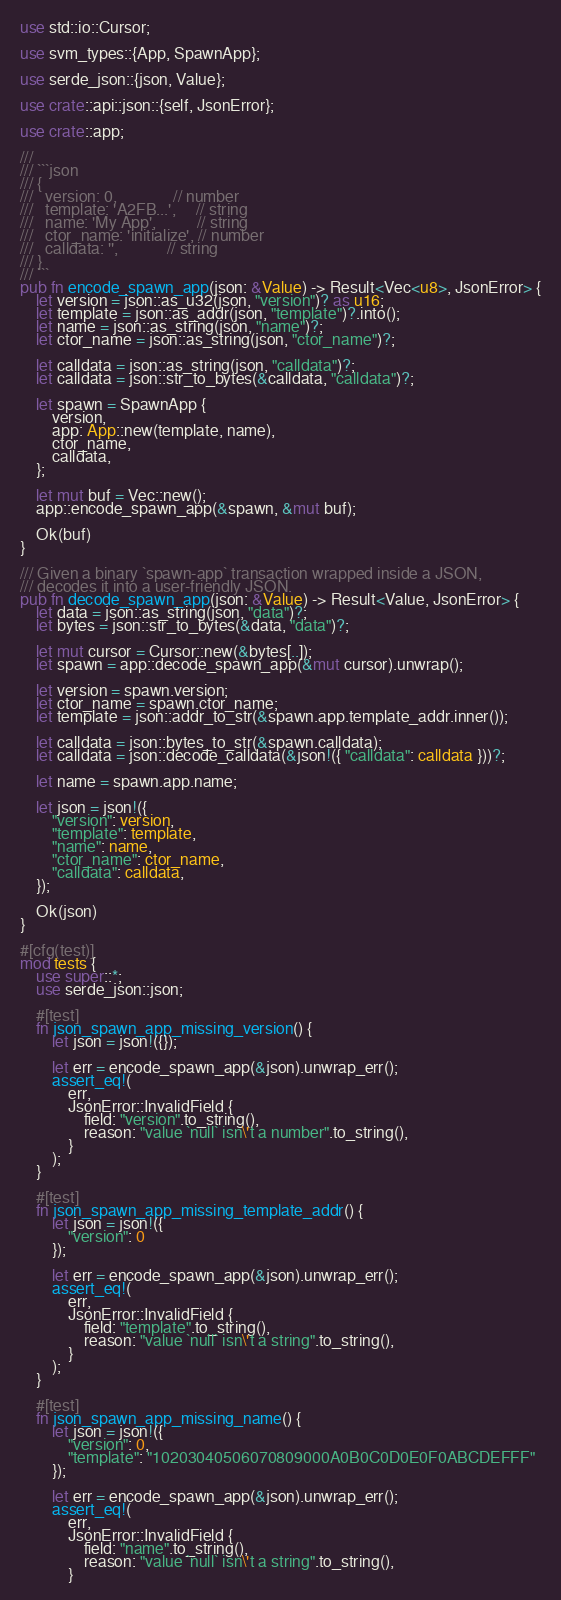<code> <loc_0><loc_0><loc_500><loc_500><_Rust_>use std::io::Cursor;

use svm_types::{App, SpawnApp};

use serde_json::{json, Value};

use crate::api::json::{self, JsonError};

use crate::app;

///
/// ```json
/// {
///   version: 0,              // number
///   template: 'A2FB...',     // string
///   name: 'My App',          // string
///   ctor_name: 'initialize', // number
///   calldata: '',            // string
/// }
/// ```
pub fn encode_spawn_app(json: &Value) -> Result<Vec<u8>, JsonError> {
    let version = json::as_u32(json, "version")? as u16;
    let template = json::as_addr(json, "template")?.into();
    let name = json::as_string(json, "name")?;
    let ctor_name = json::as_string(json, "ctor_name")?;

    let calldata = json::as_string(json, "calldata")?;
    let calldata = json::str_to_bytes(&calldata, "calldata")?;

    let spawn = SpawnApp {
        version,
        app: App::new(template, name),
        ctor_name,
        calldata,
    };

    let mut buf = Vec::new();
    app::encode_spawn_app(&spawn, &mut buf);

    Ok(buf)
}

/// Given a binary `spawn-app` transaction wrapped inside a JSON,
/// decodes it into a user-friendly JSON.
pub fn decode_spawn_app(json: &Value) -> Result<Value, JsonError> {
    let data = json::as_string(json, "data")?;
    let bytes = json::str_to_bytes(&data, "data")?;

    let mut cursor = Cursor::new(&bytes[..]);
    let spawn = app::decode_spawn_app(&mut cursor).unwrap();

    let version = spawn.version;
    let ctor_name = spawn.ctor_name;
    let template = json::addr_to_str(&spawn.app.template_addr.inner());

    let calldata = json::bytes_to_str(&spawn.calldata);
    let calldata = json::decode_calldata(&json!({ "calldata": calldata }))?;

    let name = spawn.app.name;

    let json = json!({
        "version": version,
        "template": template,
        "name": name,
        "ctor_name": ctor_name,
        "calldata": calldata,
    });

    Ok(json)
}

#[cfg(test)]
mod tests {
    use super::*;
    use serde_json::json;

    #[test]
    fn json_spawn_app_missing_version() {
        let json = json!({});

        let err = encode_spawn_app(&json).unwrap_err();
        assert_eq!(
            err,
            JsonError::InvalidField {
                field: "version".to_string(),
                reason: "value `null` isn\'t a number".to_string(),
            }
        );
    }

    #[test]
    fn json_spawn_app_missing_template_addr() {
        let json = json!({
            "version": 0
        });

        let err = encode_spawn_app(&json).unwrap_err();
        assert_eq!(
            err,
            JsonError::InvalidField {
                field: "template".to_string(),
                reason: "value `null` isn\'t a string".to_string(),
            }
        );
    }

    #[test]
    fn json_spawn_app_missing_name() {
        let json = json!({
            "version": 0,
            "template": "10203040506070809000A0B0C0D0E0F0ABCDEFFF"
        });

        let err = encode_spawn_app(&json).unwrap_err();
        assert_eq!(
            err,
            JsonError::InvalidField {
                field: "name".to_string(),
                reason: "value `null` isn\'t a string".to_string(),
            }</code> 